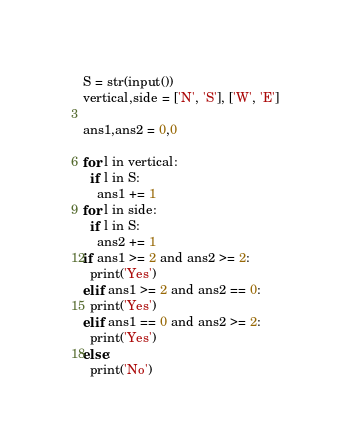<code> <loc_0><loc_0><loc_500><loc_500><_Python_>S = str(input())
vertical,side = ['N', 'S'], ['W', 'E']

ans1,ans2 = 0,0

for l in vertical:
  if l in S:
    ans1 += 1
for l in side:
  if l in S:
    ans2 += 1
if ans1 >= 2 and ans2 >= 2:
  print('Yes')
elif ans1 >= 2 and ans2 == 0:
  print('Yes')
elif ans1 == 0 and ans2 >= 2:
  print('Yes')
else:
  print('No')</code> 